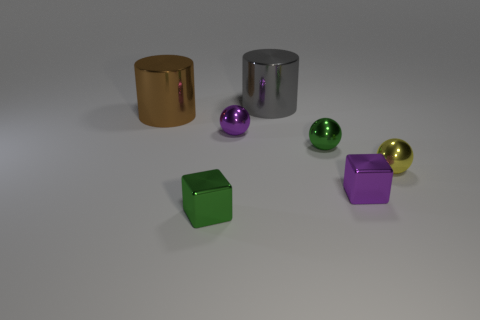The metal cylinder that is behind the brown metallic cylinder is what color?
Your answer should be compact. Gray. What is the size of the gray cylinder?
Keep it short and to the point. Large. There is a tiny shiny block that is behind the tiny green metallic thing in front of the yellow object; what color is it?
Make the answer very short. Purple. Is the shape of the green object that is behind the small green cube the same as  the yellow shiny object?
Give a very brief answer. Yes. How many shiny things are in front of the large brown cylinder and behind the green metallic ball?
Ensure brevity in your answer.  1. The big thing behind the big brown thing to the left of the tiny metallic object behind the tiny green metallic sphere is what color?
Your response must be concise. Gray. There is a small shiny cube that is in front of the small purple cube; what number of cylinders are right of it?
Your answer should be compact. 1. What number of other things are there of the same shape as the brown object?
Your answer should be very brief. 1. How many objects are big gray cylinders or small green things that are in front of the green ball?
Your answer should be compact. 2. Is the number of small metal spheres that are behind the yellow metallic sphere greater than the number of yellow things in front of the purple shiny sphere?
Your answer should be very brief. Yes. 